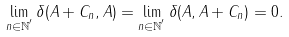<formula> <loc_0><loc_0><loc_500><loc_500>\lim _ { n \in \mathbb { N } ^ { ^ { \prime } } } \delta ( A + C _ { n } , A ) = \lim _ { n \in \mathbb { N } ^ { ^ { \prime } } } \delta ( A , A + C _ { n } ) = 0 .</formula> 